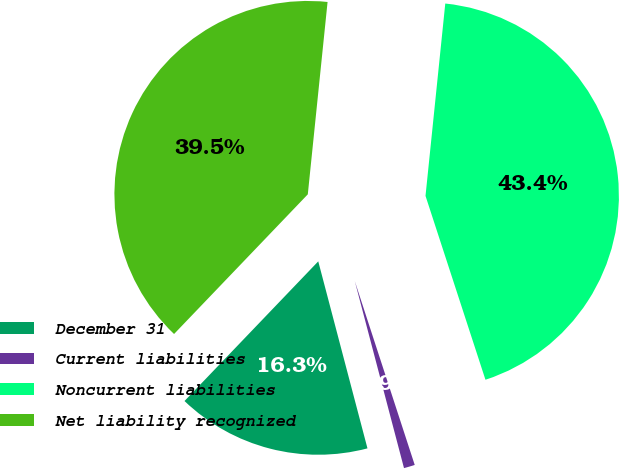<chart> <loc_0><loc_0><loc_500><loc_500><pie_chart><fcel>December 31<fcel>Current liabilities<fcel>Noncurrent liabilities<fcel>Net liability recognized<nl><fcel>16.25%<fcel>0.92%<fcel>43.35%<fcel>39.47%<nl></chart> 